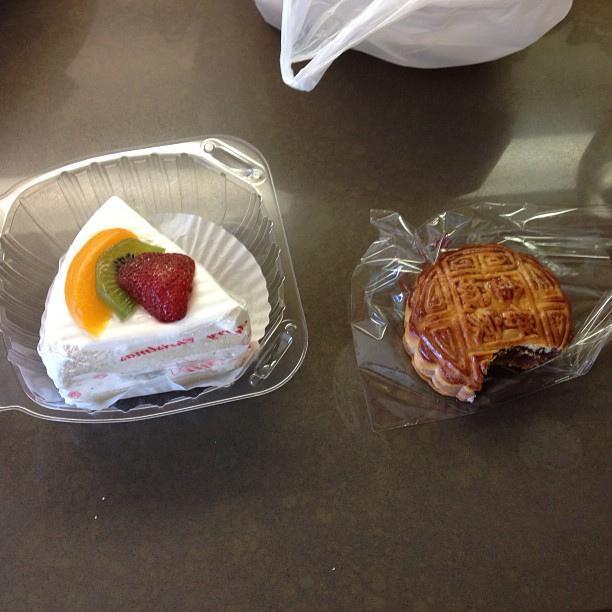How many bowls are visible?
Give a very brief answer. 1. How many cakes can be seen?
Give a very brief answer. 2. 